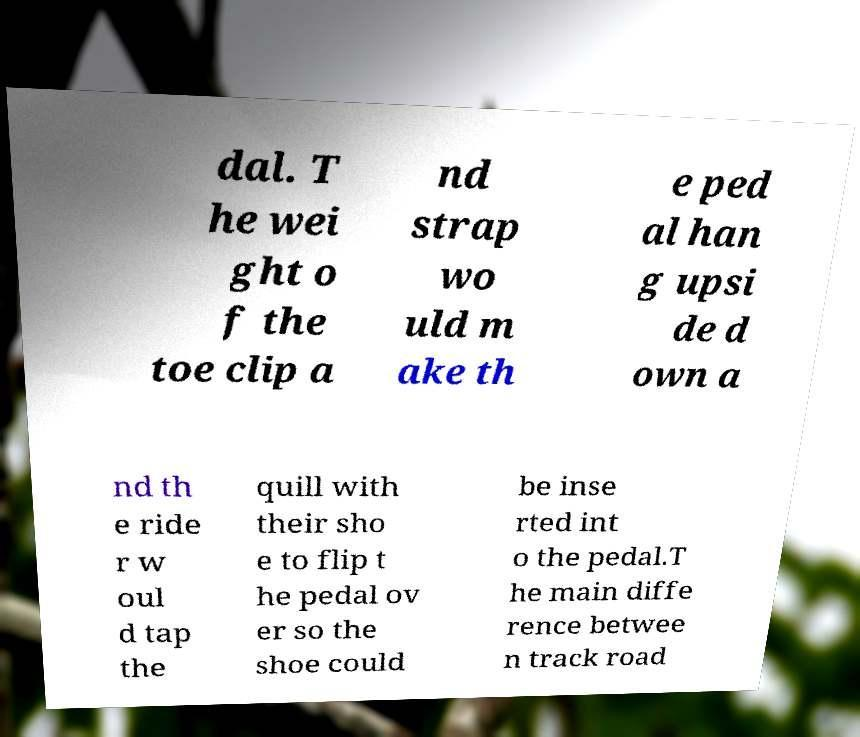There's text embedded in this image that I need extracted. Can you transcribe it verbatim? dal. T he wei ght o f the toe clip a nd strap wo uld m ake th e ped al han g upsi de d own a nd th e ride r w oul d tap the quill with their sho e to flip t he pedal ov er so the shoe could be inse rted int o the pedal.T he main diffe rence betwee n track road 